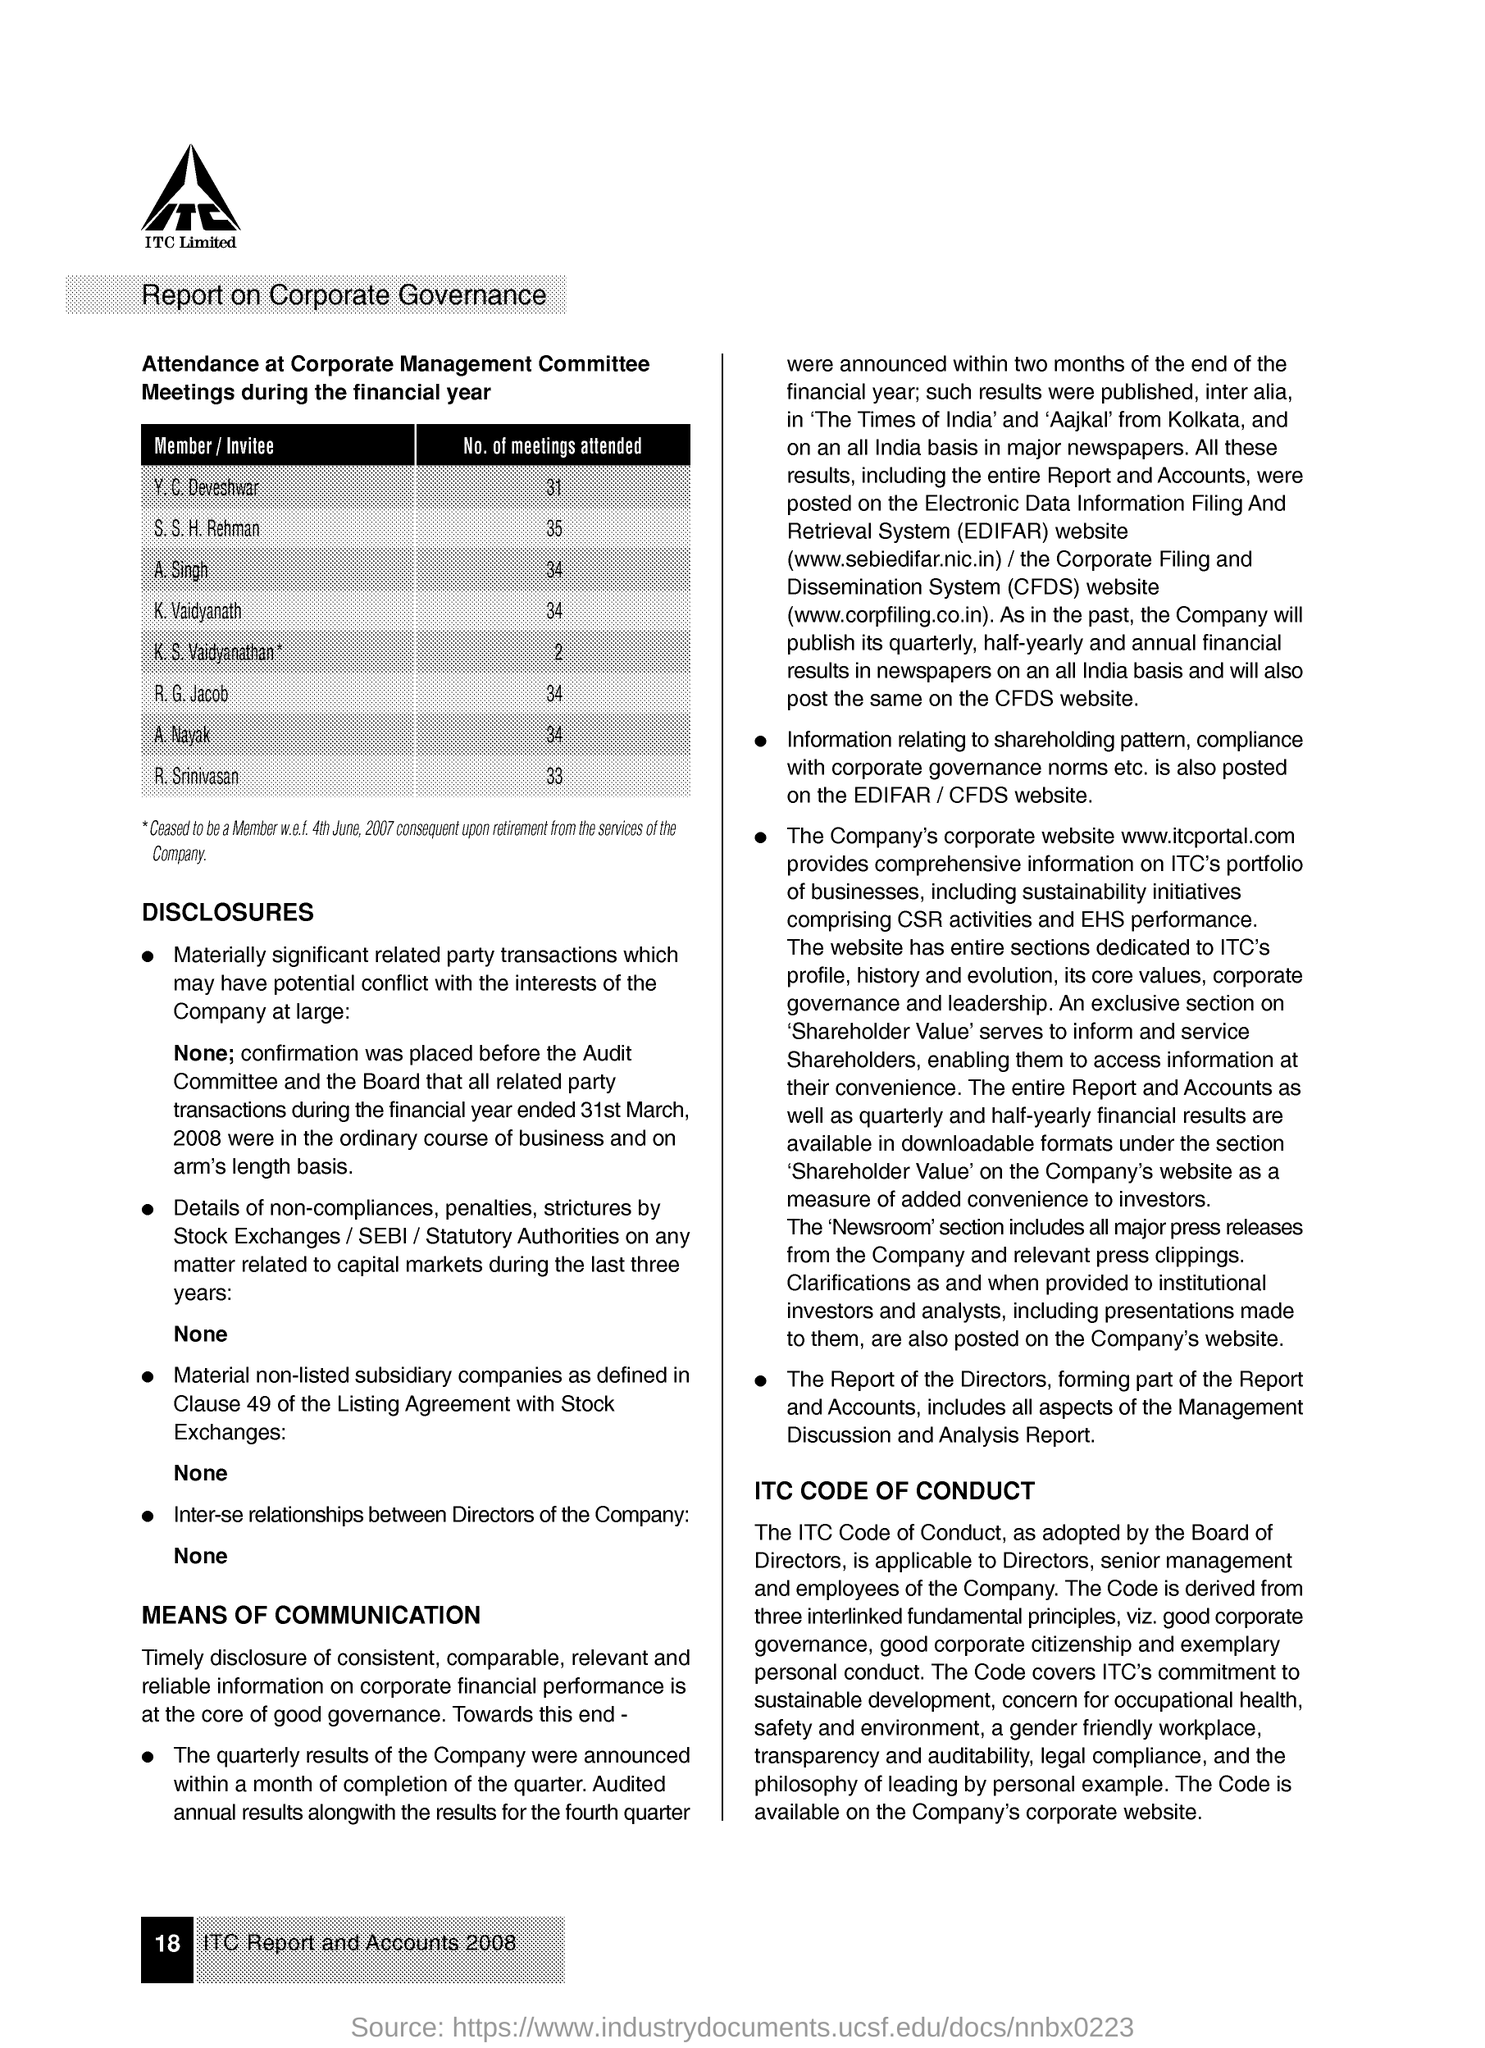Identify some key points in this picture. R.G. Jacob attended 34 meetings. A. Singh attended 34 meetings. K.S. Vaidyanathan attended 2 meetings. R. Srinivasan attended 33 meetings. K. Vaidyanath attended 34 meetings. 